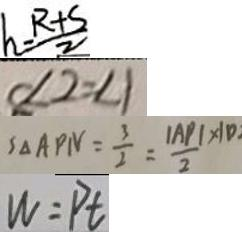<formula> <loc_0><loc_0><loc_500><loc_500>h = \frac { R + S } { 2 } 
 \angle 2 = \angle 1 
 S _ { \Delta A P N } = \frac { 3 } { 2 } = \frac { \vert A P \vert \times 1 0 } { 2 } 
 W = P t</formula> 